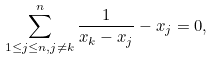<formula> <loc_0><loc_0><loc_500><loc_500>\sum _ { 1 \leq j \leq n , j \neq k } ^ { n } \frac { 1 } { x _ { k } - x _ { j } } - x _ { j } = 0 ,</formula> 